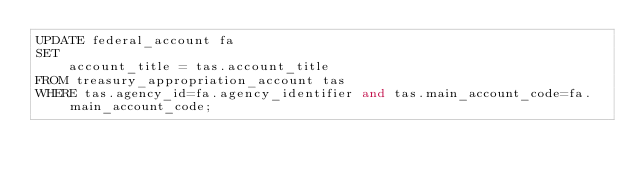<code> <loc_0><loc_0><loc_500><loc_500><_SQL_>UPDATE federal_account fa
SET
    account_title = tas.account_title
FROM treasury_appropriation_account tas
WHERE tas.agency_id=fa.agency_identifier and tas.main_account_code=fa.main_account_code;
</code> 